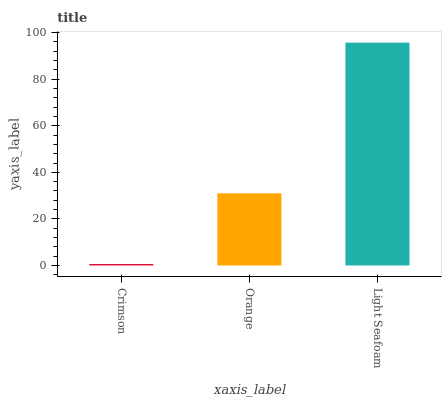Is Crimson the minimum?
Answer yes or no. Yes. Is Light Seafoam the maximum?
Answer yes or no. Yes. Is Orange the minimum?
Answer yes or no. No. Is Orange the maximum?
Answer yes or no. No. Is Orange greater than Crimson?
Answer yes or no. Yes. Is Crimson less than Orange?
Answer yes or no. Yes. Is Crimson greater than Orange?
Answer yes or no. No. Is Orange less than Crimson?
Answer yes or no. No. Is Orange the high median?
Answer yes or no. Yes. Is Orange the low median?
Answer yes or no. Yes. Is Crimson the high median?
Answer yes or no. No. Is Light Seafoam the low median?
Answer yes or no. No. 